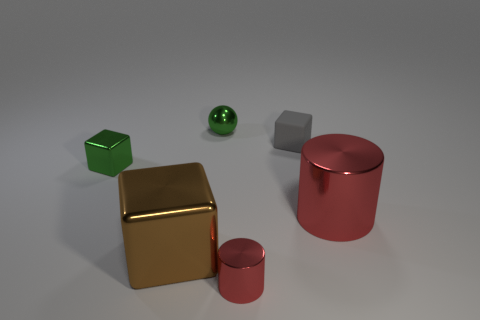Subtract all large shiny cubes. How many cubes are left? 2 Add 3 tiny matte objects. How many objects exist? 9 Subtract all brown blocks. How many blocks are left? 2 Subtract all cylinders. How many objects are left? 4 Subtract all brown spheres. Subtract all red blocks. How many spheres are left? 1 Subtract all large brown metallic things. Subtract all big brown metallic blocks. How many objects are left? 4 Add 3 green metal balls. How many green metal balls are left? 4 Add 3 gray shiny cylinders. How many gray shiny cylinders exist? 3 Subtract 0 cyan cylinders. How many objects are left? 6 